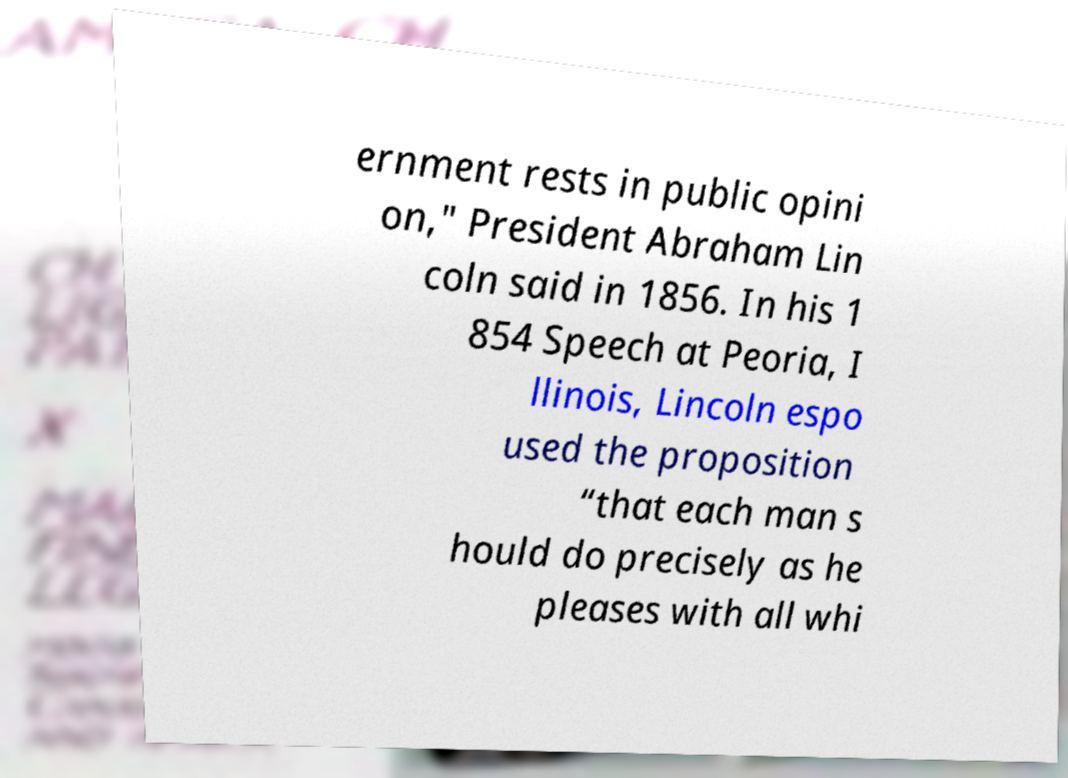I need the written content from this picture converted into text. Can you do that? ernment rests in public opini on," President Abraham Lin coln said in 1856. In his 1 854 Speech at Peoria, I llinois, Lincoln espo used the proposition “that each man s hould do precisely as he pleases with all whi 